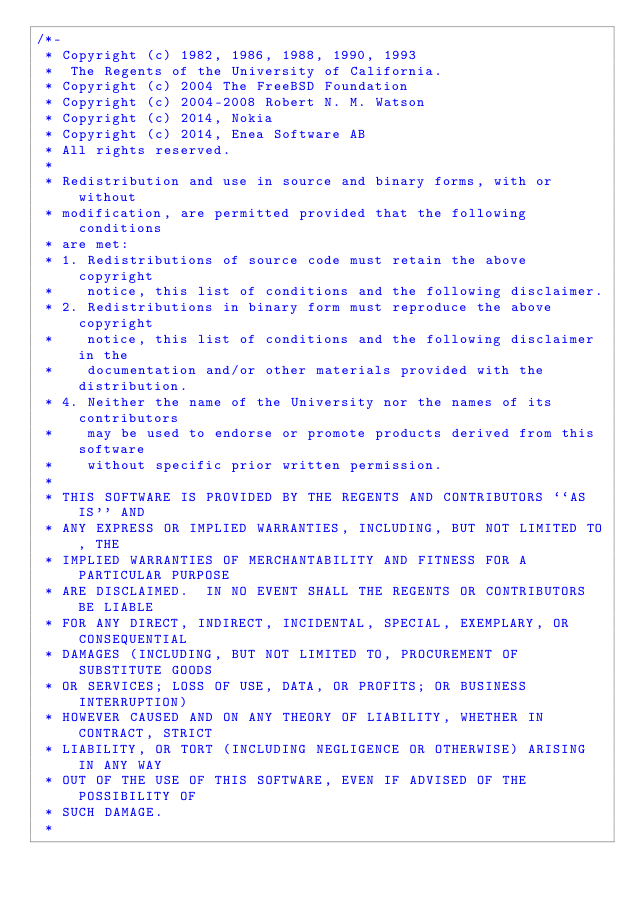<code> <loc_0><loc_0><loc_500><loc_500><_C_>/*-
 * Copyright (c) 1982, 1986, 1988, 1990, 1993
 *	The Regents of the University of California.
 * Copyright (c) 2004 The FreeBSD Foundation
 * Copyright (c) 2004-2008 Robert N. M. Watson
 * Copyright (c) 2014, Nokia
 * Copyright (c) 2014, Enea Software AB
 * All rights reserved.
 *
 * Redistribution and use in source and binary forms, with or without
 * modification, are permitted provided that the following conditions
 * are met:
 * 1. Redistributions of source code must retain the above copyright
 *    notice, this list of conditions and the following disclaimer.
 * 2. Redistributions in binary form must reproduce the above copyright
 *    notice, this list of conditions and the following disclaimer in the
 *    documentation and/or other materials provided with the distribution.
 * 4. Neither the name of the University nor the names of its contributors
 *    may be used to endorse or promote products derived from this software
 *    without specific prior written permission.
 *
 * THIS SOFTWARE IS PROVIDED BY THE REGENTS AND CONTRIBUTORS ``AS IS'' AND
 * ANY EXPRESS OR IMPLIED WARRANTIES, INCLUDING, BUT NOT LIMITED TO, THE
 * IMPLIED WARRANTIES OF MERCHANTABILITY AND FITNESS FOR A PARTICULAR PURPOSE
 * ARE DISCLAIMED.  IN NO EVENT SHALL THE REGENTS OR CONTRIBUTORS BE LIABLE
 * FOR ANY DIRECT, INDIRECT, INCIDENTAL, SPECIAL, EXEMPLARY, OR CONSEQUENTIAL
 * DAMAGES (INCLUDING, BUT NOT LIMITED TO, PROCUREMENT OF SUBSTITUTE GOODS
 * OR SERVICES; LOSS OF USE, DATA, OR PROFITS; OR BUSINESS INTERRUPTION)
 * HOWEVER CAUSED AND ON ANY THEORY OF LIABILITY, WHETHER IN CONTRACT, STRICT
 * LIABILITY, OR TORT (INCLUDING NEGLIGENCE OR OTHERWISE) ARISING IN ANY WAY
 * OUT OF THE USE OF THIS SOFTWARE, EVEN IF ADVISED OF THE POSSIBILITY OF
 * SUCH DAMAGE.
 *</code> 